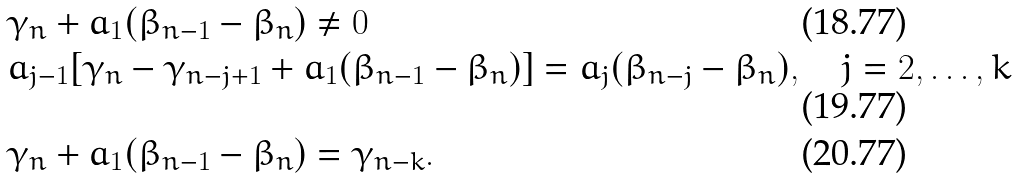Convert formula to latex. <formula><loc_0><loc_0><loc_500><loc_500>& \gamma _ { n } + a _ { 1 } ( \beta _ { n - 1 } - \beta _ { n } ) \not = 0 \\ & a _ { j - 1 } [ \gamma _ { n } - \gamma _ { n - j + 1 } + a _ { 1 } ( \beta _ { n - 1 } - \beta _ { n } ) ] = a _ { j } ( \beta _ { n - j } - \beta _ { n } ) , \quad j = 2 , \dots , k \\ & \gamma _ { n } + a _ { 1 } ( \beta _ { n - 1 } - \beta _ { n } ) = \gamma _ { n - k } .</formula> 